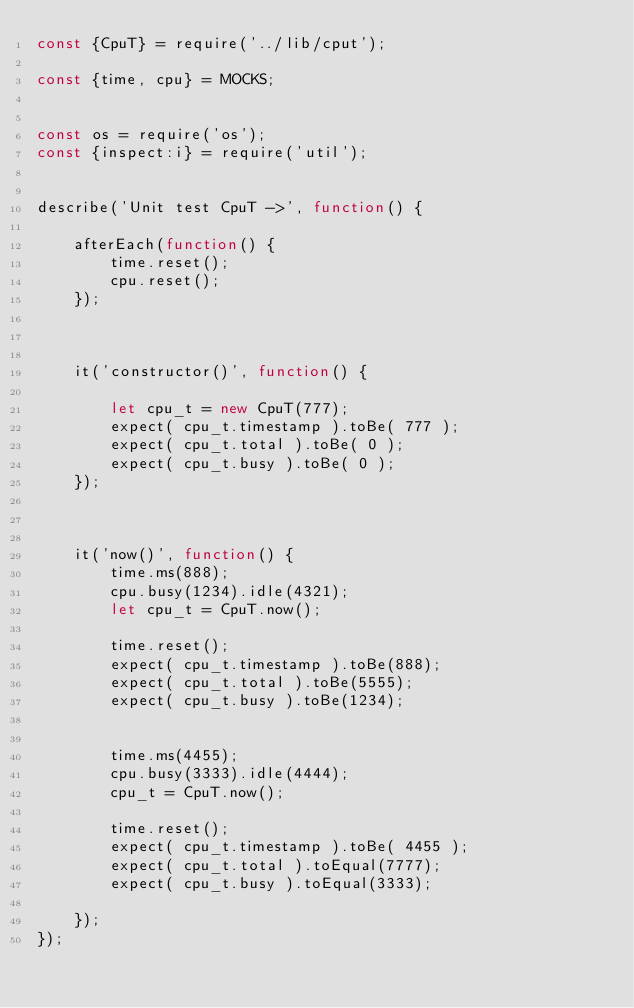<code> <loc_0><loc_0><loc_500><loc_500><_JavaScript_>const {CpuT} = require('../lib/cput');

const {time, cpu} = MOCKS;


const os = require('os');
const {inspect:i} = require('util');


describe('Unit test CpuT ->', function() {

    afterEach(function() {
        time.reset();
        cpu.reset();
    });



    it('constructor()', function() {

        let cpu_t = new CpuT(777);
        expect( cpu_t.timestamp ).toBe( 777 );
        expect( cpu_t.total ).toBe( 0 );
        expect( cpu_t.busy ).toBe( 0 );
    });



    it('now()', function() {
        time.ms(888);
        cpu.busy(1234).idle(4321);
        let cpu_t = CpuT.now();
        
        time.reset();
        expect( cpu_t.timestamp ).toBe(888);
        expect( cpu_t.total ).toBe(5555);
        expect( cpu_t.busy ).toBe(1234);


        time.ms(4455);
        cpu.busy(3333).idle(4444);        
        cpu_t = CpuT.now();
        
        time.reset();
        expect( cpu_t.timestamp ).toBe( 4455 );
        expect( cpu_t.total ).toEqual(7777);
        expect( cpu_t.busy ).toEqual(3333);

    });
});

</code> 